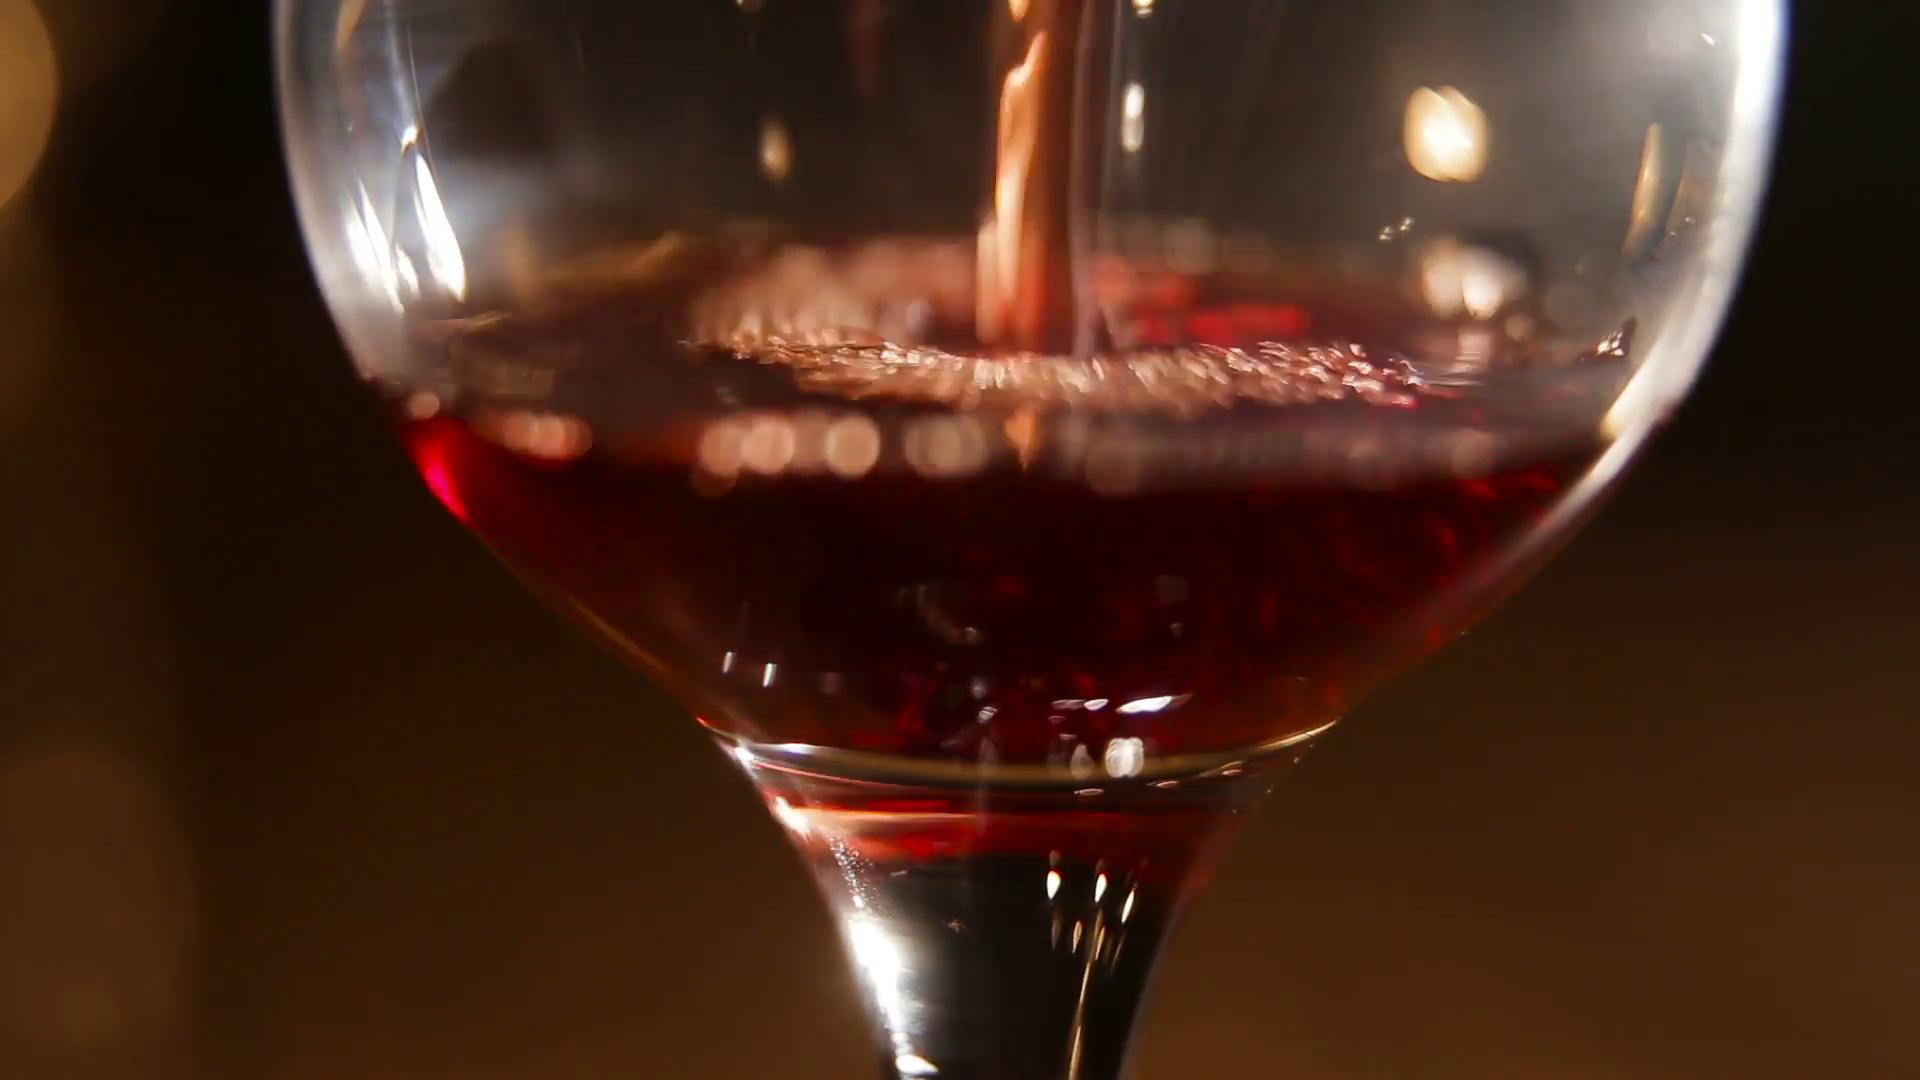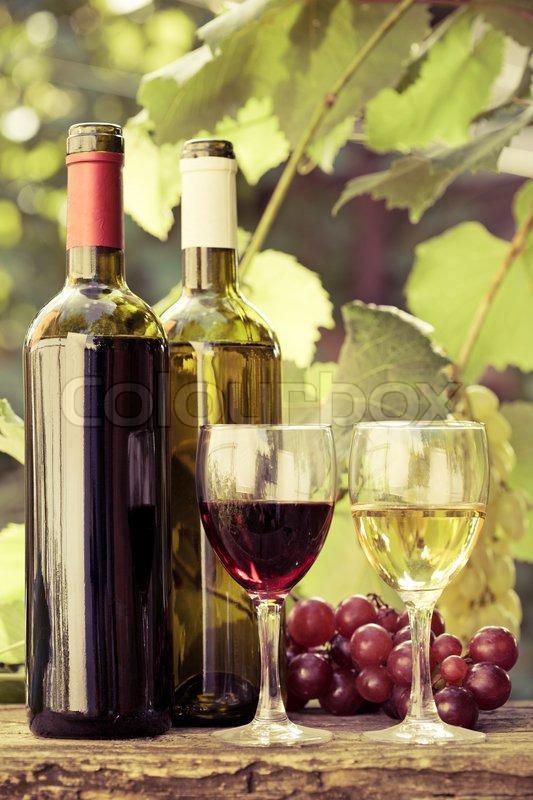The first image is the image on the left, the second image is the image on the right. For the images shown, is this caption "An image shows wine bottle, glass, grapes and green leaves." true? Answer yes or no. Yes. The first image is the image on the left, the second image is the image on the right. For the images displayed, is the sentence "there is exactly one bottle in the image on the right" factually correct? Answer yes or no. No. 